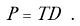Convert formula to latex. <formula><loc_0><loc_0><loc_500><loc_500>P = T D \ .</formula> 